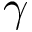Convert formula to latex. <formula><loc_0><loc_0><loc_500><loc_500>\gamma</formula> 